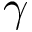Convert formula to latex. <formula><loc_0><loc_0><loc_500><loc_500>\gamma</formula> 